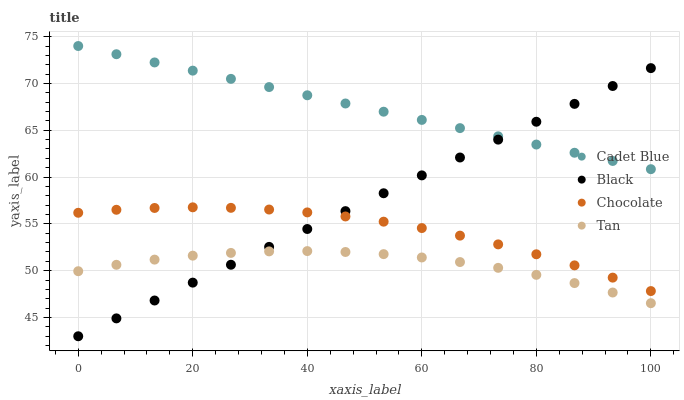Does Tan have the minimum area under the curve?
Answer yes or no. Yes. Does Cadet Blue have the maximum area under the curve?
Answer yes or no. Yes. Does Black have the minimum area under the curve?
Answer yes or no. No. Does Black have the maximum area under the curve?
Answer yes or no. No. Is Black the smoothest?
Answer yes or no. Yes. Is Tan the roughest?
Answer yes or no. Yes. Is Cadet Blue the smoothest?
Answer yes or no. No. Is Cadet Blue the roughest?
Answer yes or no. No. Does Black have the lowest value?
Answer yes or no. Yes. Does Cadet Blue have the lowest value?
Answer yes or no. No. Does Cadet Blue have the highest value?
Answer yes or no. Yes. Does Black have the highest value?
Answer yes or no. No. Is Tan less than Cadet Blue?
Answer yes or no. Yes. Is Cadet Blue greater than Chocolate?
Answer yes or no. Yes. Does Chocolate intersect Black?
Answer yes or no. Yes. Is Chocolate less than Black?
Answer yes or no. No. Is Chocolate greater than Black?
Answer yes or no. No. Does Tan intersect Cadet Blue?
Answer yes or no. No. 